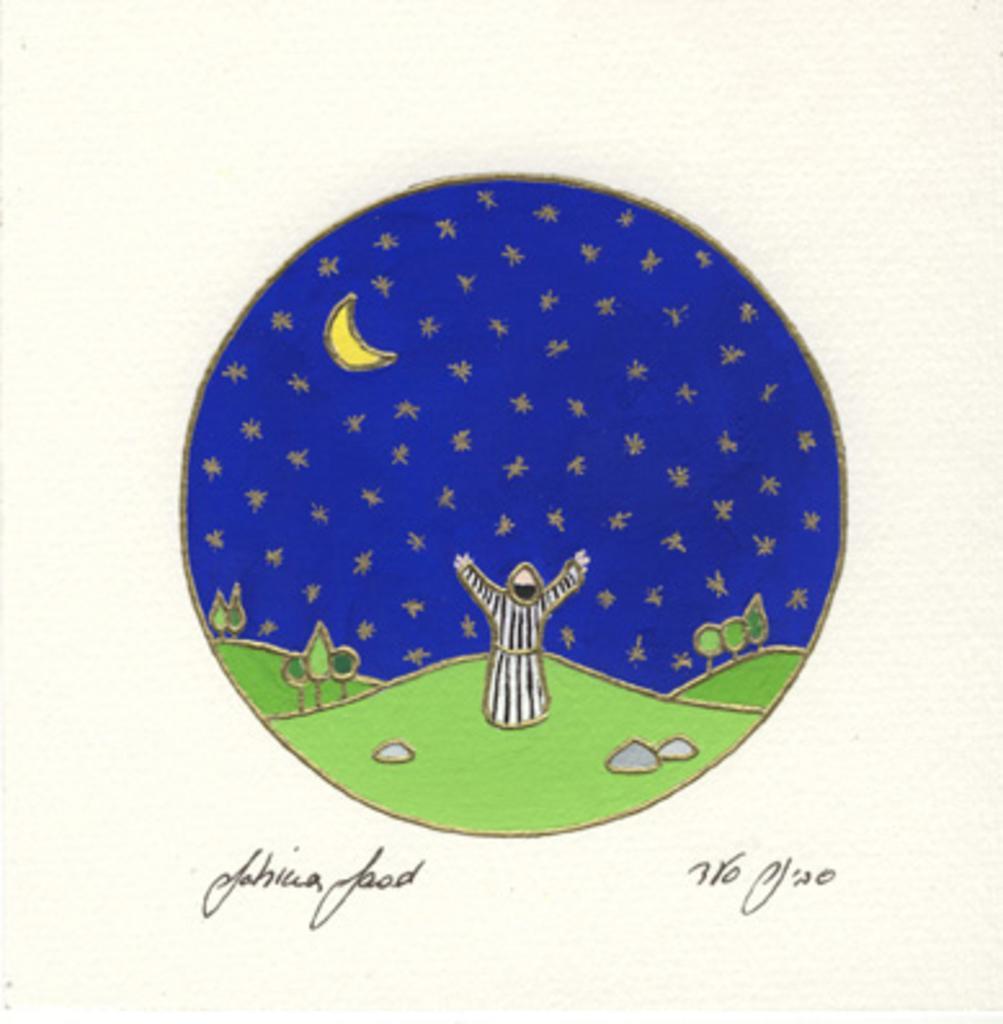In one or two sentences, can you explain what this image depicts? The picture looks like a card. In the center of the picture we can see the drawing of grasslands, person, tree, sky and moon. At the bottom there is text. 